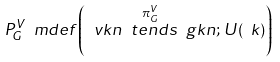<formula> <loc_0><loc_0><loc_500><loc_500>P ^ { V } _ { G } \ m d e f \left ( \ v k n \overset { \pi ^ { V } _ { G } } { \ t e n d s } \ g k n ; \, U ( \ k ) \right )</formula> 